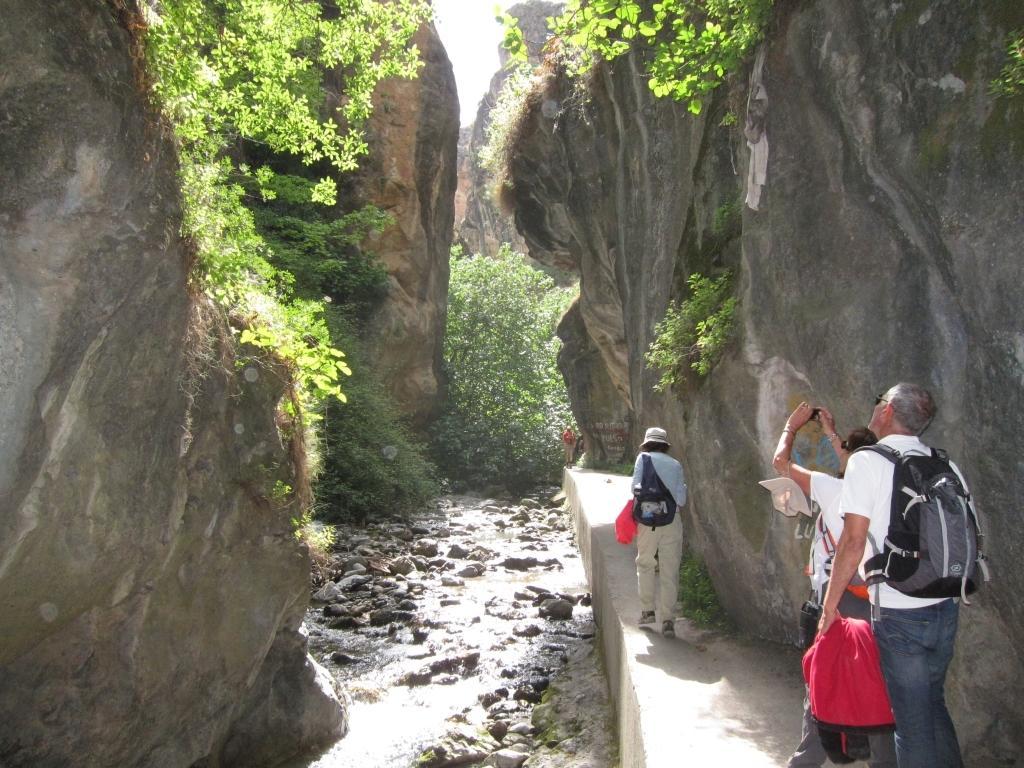How would you summarize this image in a sentence or two? In this image we can see the rock hills, plants, stones and also the trees. We can also the people on the path. Sky is also visible. 